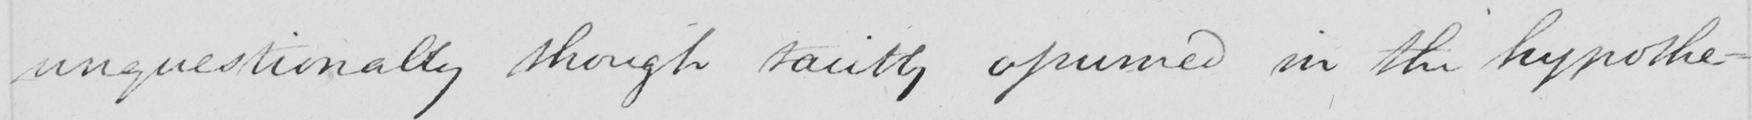Please provide the text content of this handwritten line. unquestionably though tacitly assumed in the hypothe- 